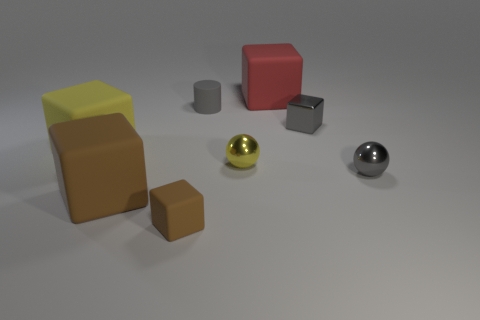Subtract all large yellow blocks. How many blocks are left? 4 Add 1 tiny green things. How many objects exist? 9 Subtract 1 cylinders. How many cylinders are left? 0 Subtract all red blocks. How many blocks are left? 4 Subtract all balls. How many objects are left? 6 Subtract all cyan cylinders. Subtract all green blocks. How many cylinders are left? 1 Subtract all brown balls. How many yellow cubes are left? 1 Subtract all green rubber cubes. Subtract all red cubes. How many objects are left? 7 Add 1 spheres. How many spheres are left? 3 Add 6 small cyan shiny blocks. How many small cyan shiny blocks exist? 6 